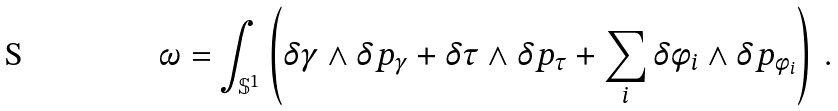Convert formula to latex. <formula><loc_0><loc_0><loc_500><loc_500>\omega = \int _ { \mathbb { S } ^ { 1 } } \left ( \delta \gamma \wedge \delta p _ { \gamma } + \delta \tau \wedge \delta p _ { \tau } + \sum _ { i } \delta \phi _ { i } \wedge \delta p _ { \phi _ { i } } \right ) \, .</formula> 